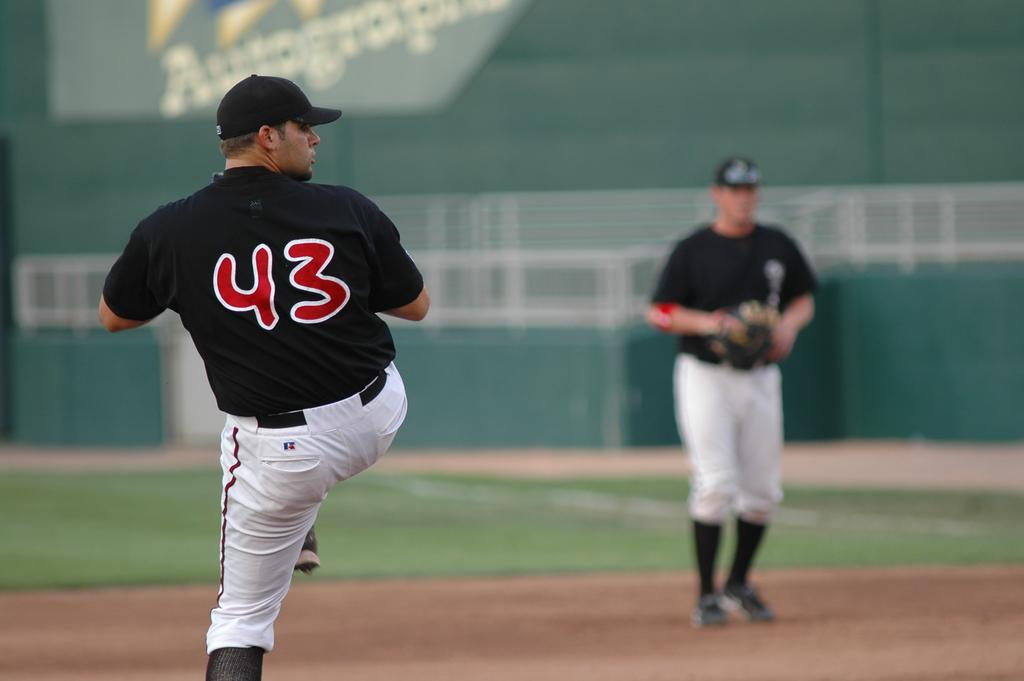<image>
Write a terse but informative summary of the picture. A baseball game is underway and the pitcher's uniform says 43 on the back. 